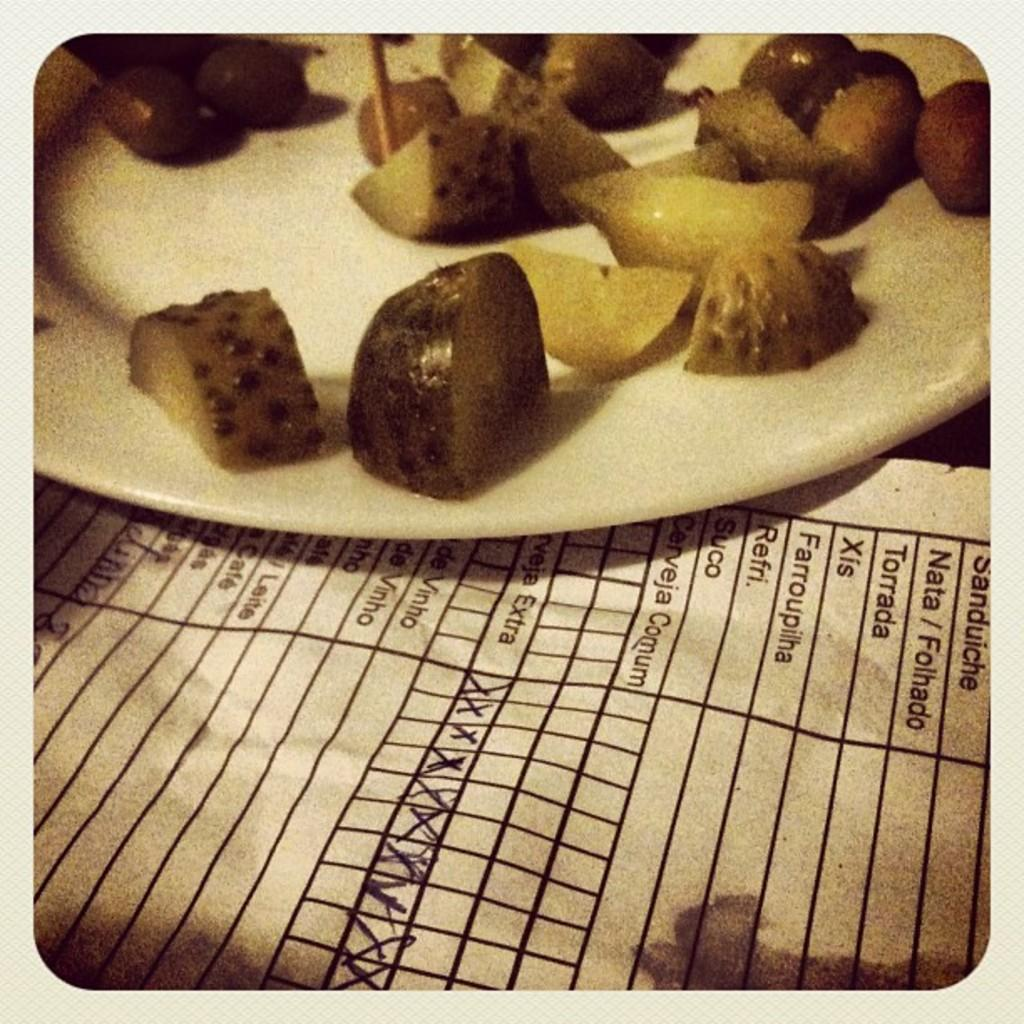What is on the plate in the image? There are fruit pieces on the plate in the image. What else can be seen near the plate? There are papers beside the plate. Can you describe the content of the papers? Text is visible on the papers. What type of treatment is the judge providing in the image? There is no judge or treatment present in the image; it only features a plate with fruit pieces and papers with text. 